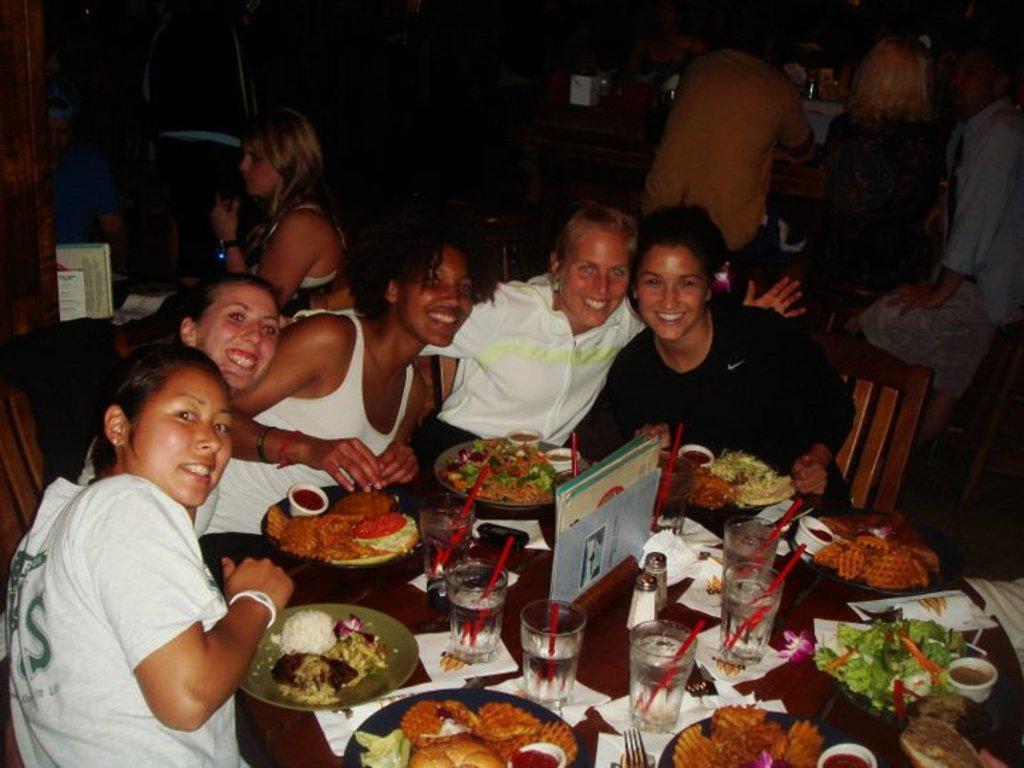Describe this image in one or two sentences. In this image we can see a group of people sitting on the chairs beside a table containing some food in the plates, glasses and straws in it, some papers and objects placed on it. On the backside we can see some people. 